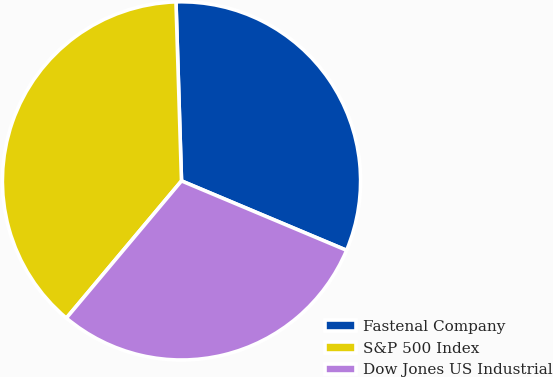<chart> <loc_0><loc_0><loc_500><loc_500><pie_chart><fcel>Fastenal Company<fcel>S&P 500 Index<fcel>Dow Jones US Industrial<nl><fcel>31.83%<fcel>38.4%<fcel>29.78%<nl></chart> 